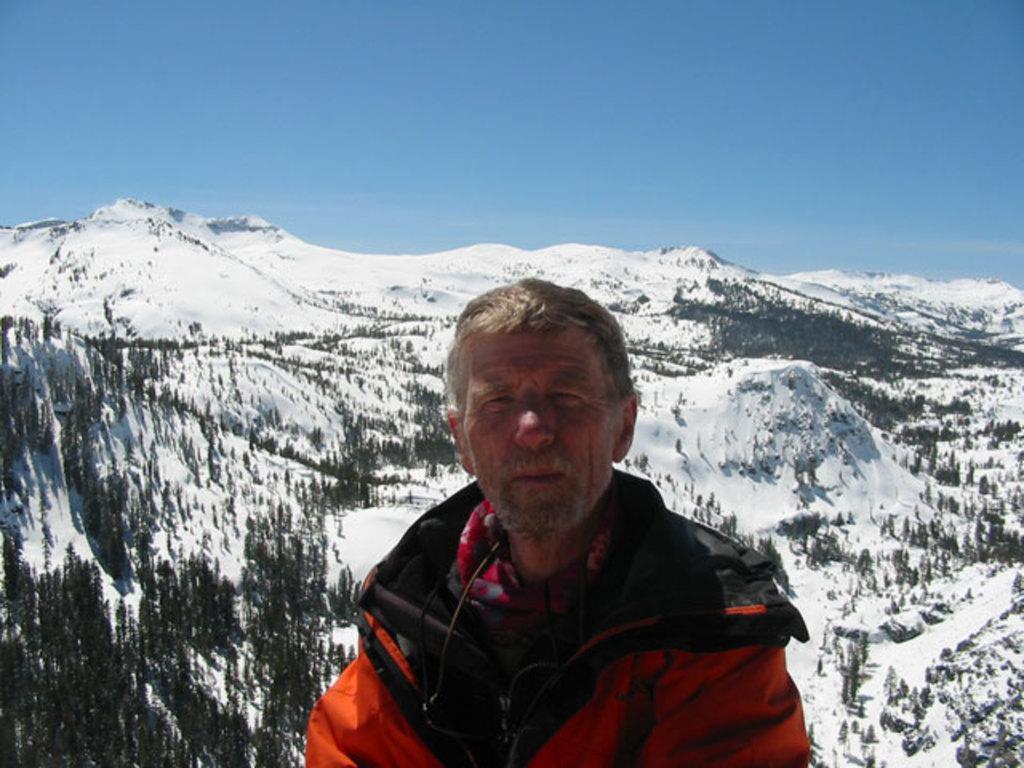Could you give a brief overview of what you see in this image? In this picture there is a old man wearing red color jacket standing and looking into the camera. Behind there is a huge mountain with some trees. 